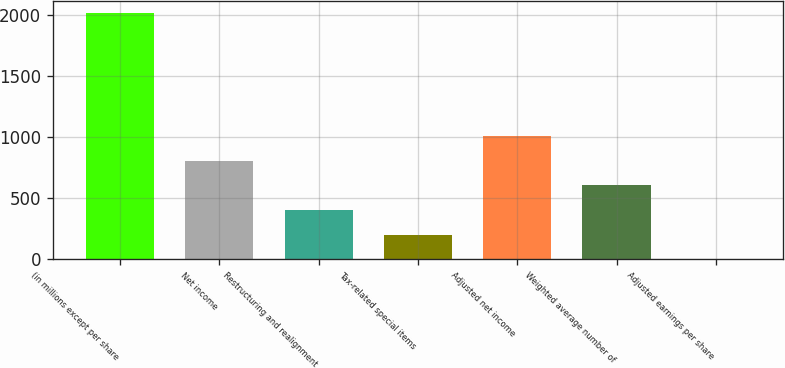Convert chart. <chart><loc_0><loc_0><loc_500><loc_500><bar_chart><fcel>(in millions except per share<fcel>Net income<fcel>Restructuring and realignment<fcel>Tax-related special items<fcel>Adjusted net income<fcel>Weighted average number of<fcel>Adjusted earnings per share<nl><fcel>2014<fcel>806.77<fcel>404.37<fcel>203.17<fcel>1007.97<fcel>605.57<fcel>1.97<nl></chart> 